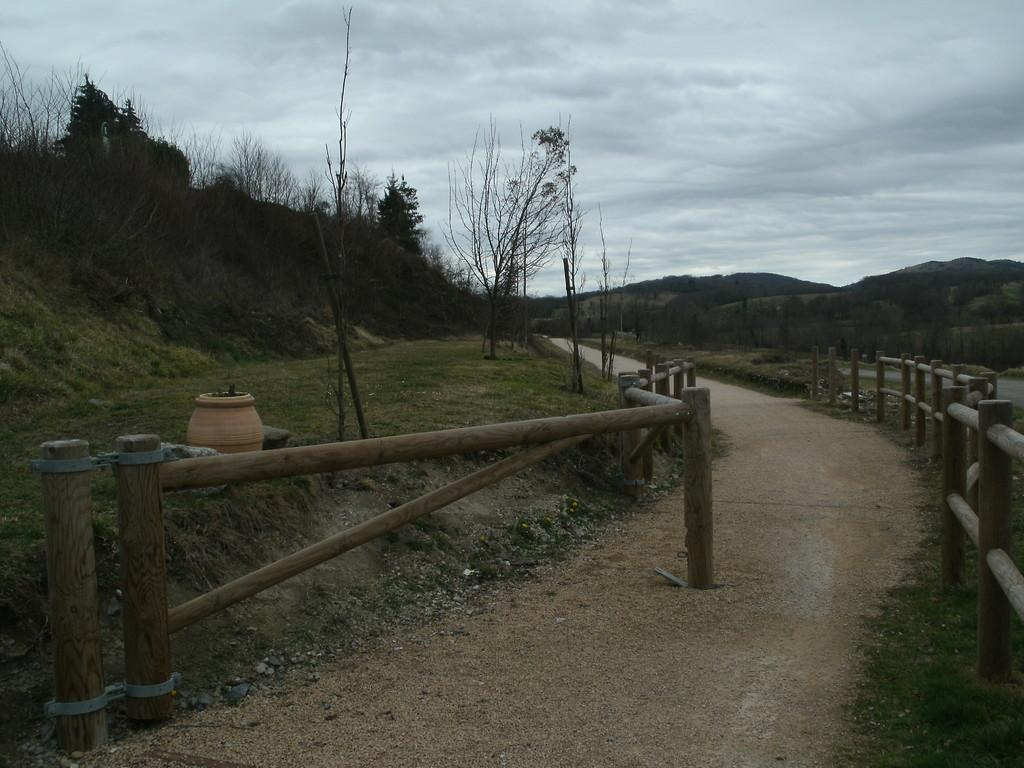What type of road is visible in the image? There is a dirt road in the image. What feature can be seen on both sides of the dirt road? The dirt road has wooden fences on both sides. What object is present in the image besides the dirt road and fences? There is a pot in the image. What type of vegetation is present in the image? Grass is present in the image, and trees are visible on the right side and at the right back of the image. What grade is the daughter in, and where is her desk located in the image? There is no daughter or desk present in the image. 